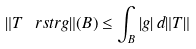Convert formula to latex. <formula><loc_0><loc_0><loc_500><loc_500>\| T \ r s t r g \| ( B ) \leq \int _ { B } | g | \, d \| T \|</formula> 